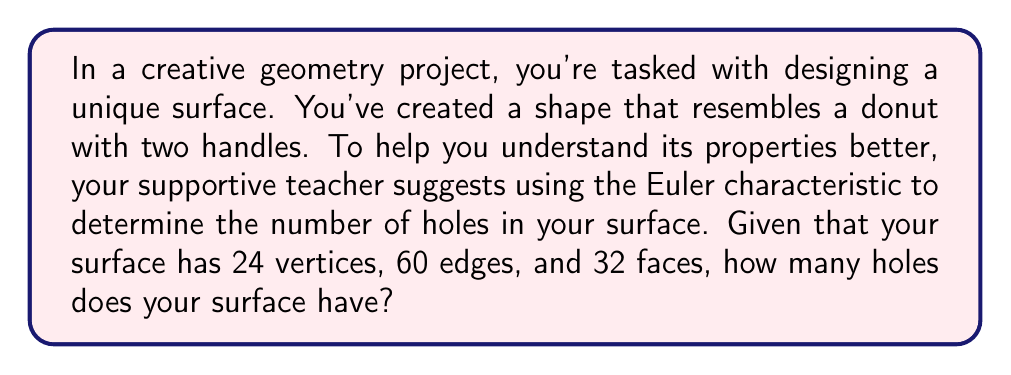Can you solve this math problem? Let's approach this step-by-step:

1) First, recall the Euler characteristic formula for a surface:

   $$\chi = V - E + F$$

   where $\chi$ is the Euler characteristic, $V$ is the number of vertices, $E$ is the number of edges, and $F$ is the number of faces.

2) We're given that:
   $V = 24$
   $E = 60$
   $F = 32$

3) Let's substitute these values into the Euler characteristic formula:

   $$\chi = 24 - 60 + 32 = -4$$

4) Now, we need to relate the Euler characteristic to the number of holes (genus) in the surface. For a closed orientable surface, the relationship is:

   $$\chi = 2 - 2g$$

   where $g$ is the genus (number of holes) of the surface.

5) We found that $\chi = -4$, so let's substitute this:

   $$-4 = 2 - 2g$$

6) Solve for $g$:
   $$-6 = -2g$$
   $$g = 3$$

Therefore, your surface has 3 holes.

This aligns with your initial description of a "donut with two handles", as a donut (torus) has one hole, and each handle adds an additional hole.
Answer: The surface has 3 holes. 